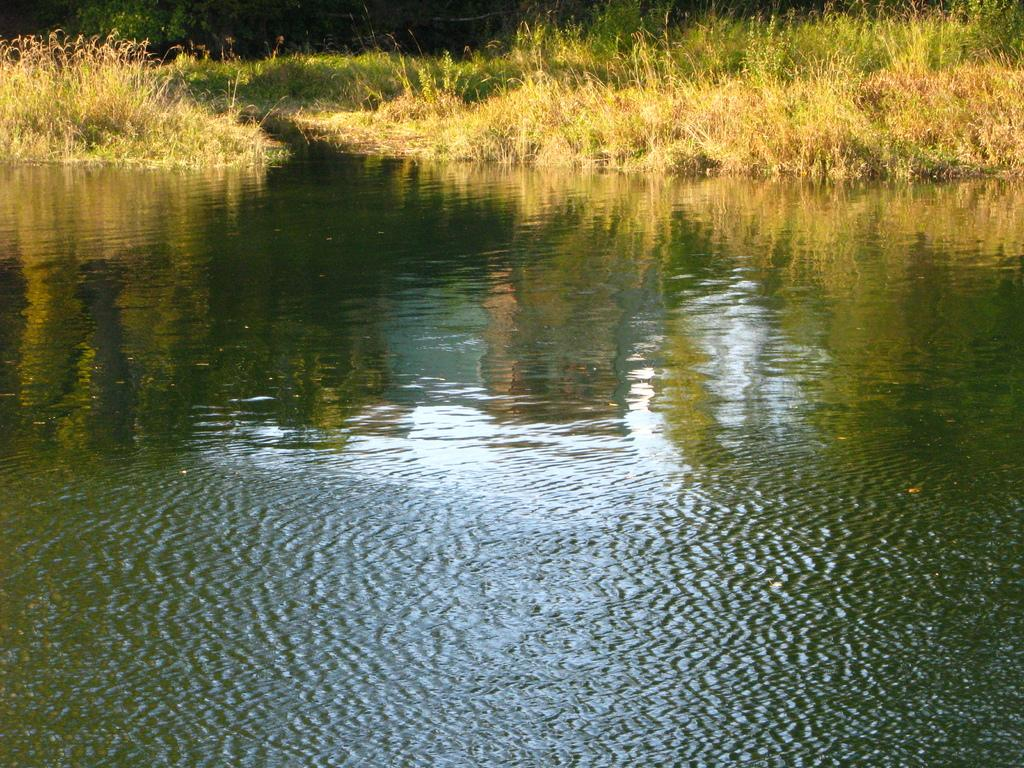What is the primary element visible in the image? Water is visible in the image. What type of vegetation can be seen in the image? There is grass and plants in the image. What type of war is depicted in the image? There is no war depicted in the image; it features water and vegetation. How does the image control the viewer's emotions? The image does not control the viewer's emotions; it is a still image of water and vegetation. 